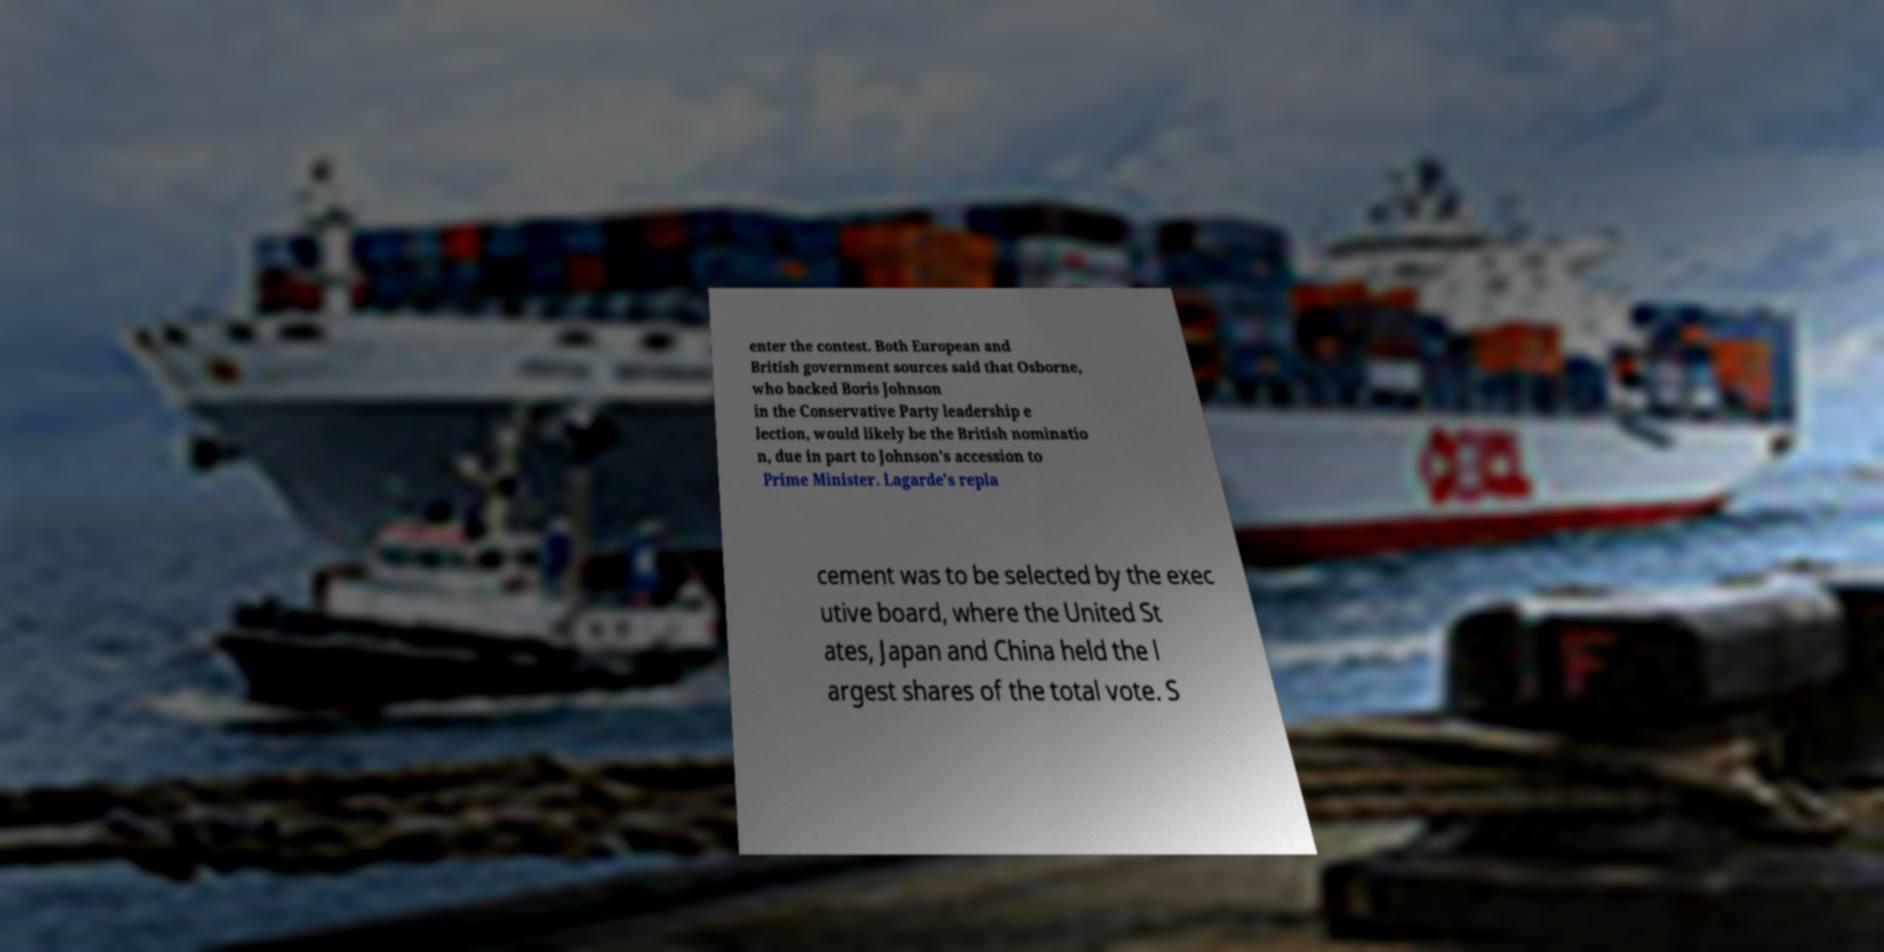Can you accurately transcribe the text from the provided image for me? enter the contest. Both European and British government sources said that Osborne, who backed Boris Johnson in the Conservative Party leadership e lection, would likely be the British nominatio n, due in part to Johnson's accession to Prime Minister. Lagarde's repla cement was to be selected by the exec utive board, where the United St ates, Japan and China held the l argest shares of the total vote. S 